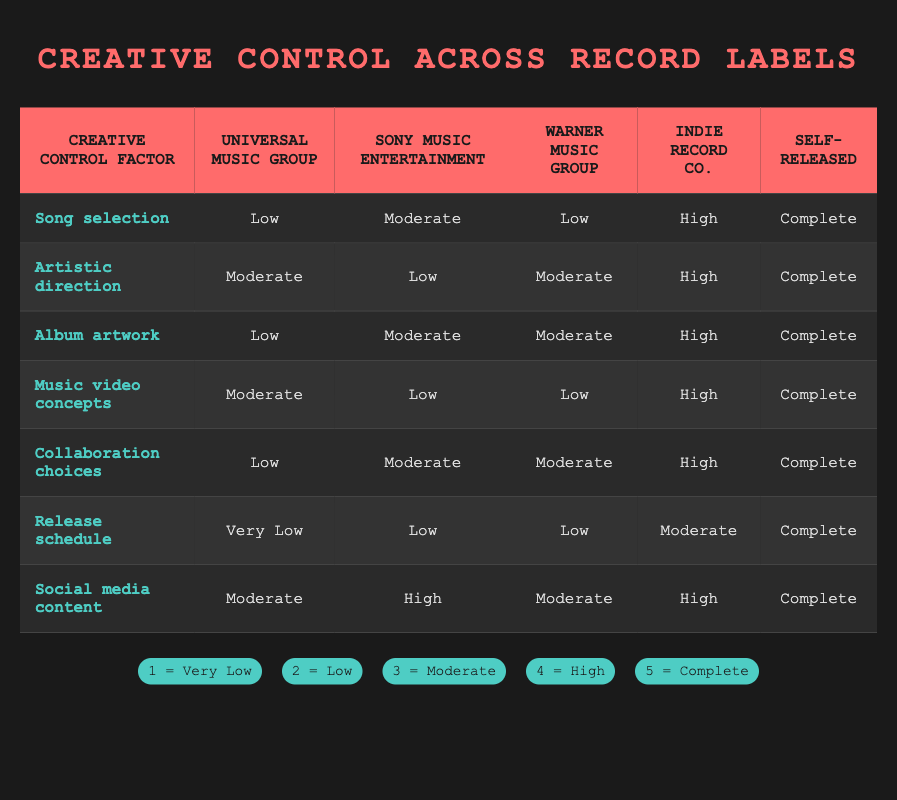What is the level of social media content control for Indie Record Co.? From the table, we can see that Indie Record Co. has a rating of 4 for social media content, which corresponds to "High" on the given scale.
Answer: High Which record label offers the least amount of artistic direction control? By examining the artistic direction row, Sony Music Entertainment has the lowest rating of 2, which is categorized as "Low" in the table.
Answer: Low What is the range of creative control for song selection across all labels? The song selection ratings are: Universal Music Group (2), Sony Music Entertainment (3), Warner Music Group (2), Indie Record Co. (4), and Self-Released (5). The maximum is 5 and the minimum is 2, so the range is 5 - 2 = 3.
Answer: 3 Does Warner Music Group have complete creative control over album artwork? By checking the album artwork row, Warner Music Group has a rating of 3, which means they do not have complete control since complete is rated as 5.
Answer: No Which record label gives the most creative control in terms of release schedule? The ratings for release schedule are: Universal Music Group (1), Sony Music Entertainment (2), Warner Music Group (2), Indie Record Co. (3), and Self-Released (5). Self-Released has the highest rating of 5.
Answer: Self-Released What is the average control level for collaboration choices across all labels? The ratings for collaboration choices are: Universal Music Group (2), Sony Music Entertainment (3), Warner Music Group (3), Indie Record Co. (4), and Self-Released (5). Adding these gives us 2 + 3 + 3 + 4 + 5 = 17. There are 5 labels, so the average is 17 / 5 = 3.4.
Answer: 3.4 Which factor has the highest level of creative control for Self-Released artists? From the Self-Released row, all factors (song selection, artistic direction, album artwork, music video concepts, collaboration choices, release schedule, social media content) have a rating of 5, meaning they have complete control.
Answer: All factors have complete control How does the level of music video concept control compare between Sony Music Entertainment and Warner Music Group? From the table, Sony Music Entertainment has a rating of 2 for music video concepts (Low), while Warner Music Group has a lower rating of 2, which is also categorized as "Low". Both have the same level of control.
Answer: They are the same (both Low) 